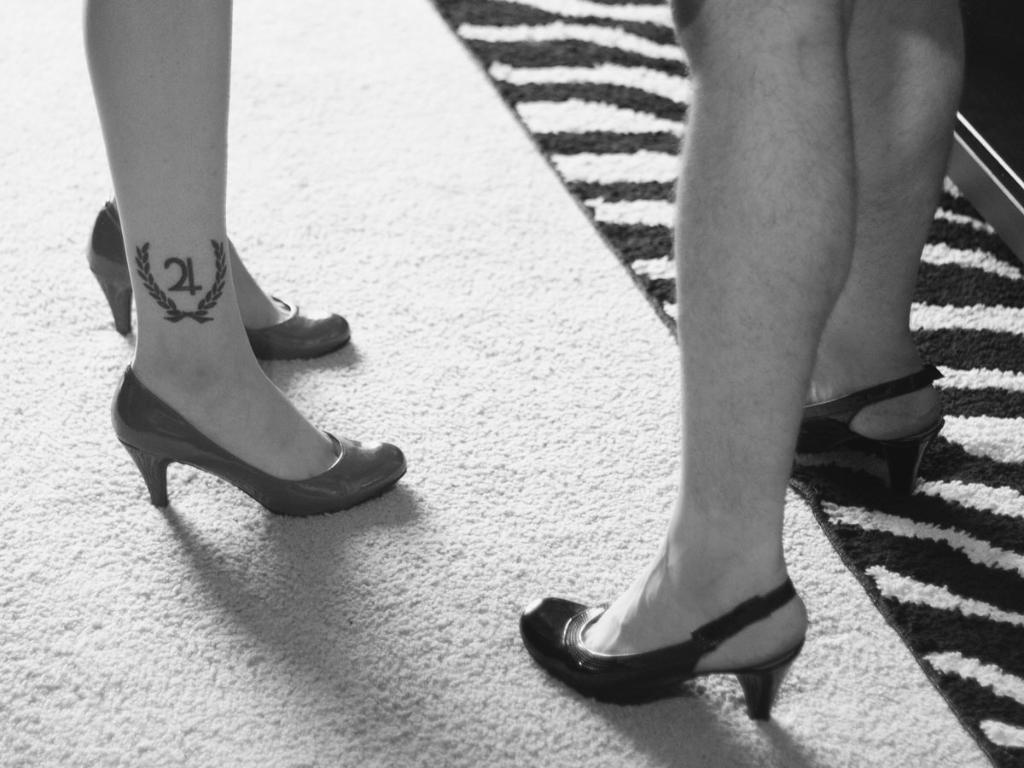What can be seen in the image regarding the subjects? There are women standing in the image. What part of their bodies is visible? Their legs are visible in the image. What is on the floor in the image? There is a carpet on the floor in the image. Can you describe any additional features of the women? One of the women has a tattoo on her leg. What type of weather can be seen in the image? The image does not show any weather conditions; it is focused on the women and the carpet. What nation are the women representing in the image? The image does not provide any information about the nationality of the women. 